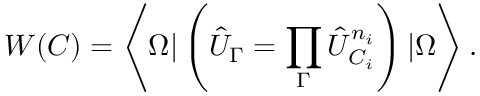<formula> <loc_0><loc_0><loc_500><loc_500>W ( C ) = \left \langle \Omega | \left ( \hat { U } _ { \Gamma } = \prod _ { \Gamma } \hat { U } _ { C _ { i } } ^ { n _ { i } } \right ) | \Omega \right \rangle .</formula> 